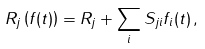<formula> <loc_0><loc_0><loc_500><loc_500>R _ { j } \left ( f ( t ) \right ) = R _ { j } + \sum _ { i } S _ { j i } f _ { i } ( t ) \, ,</formula> 